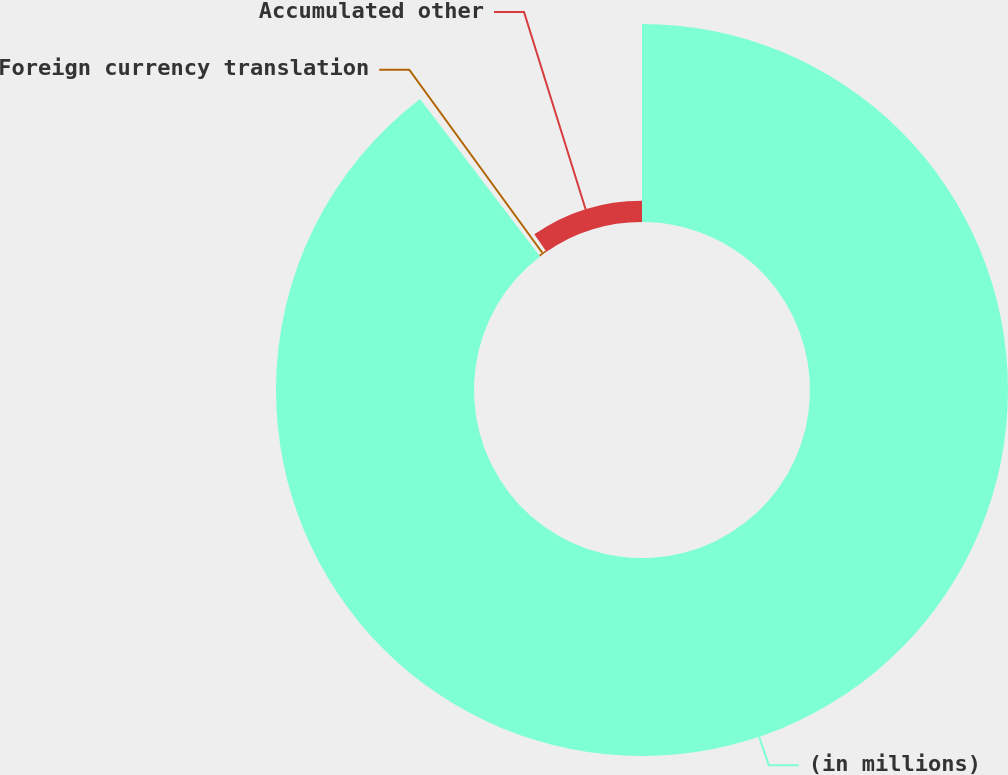Convert chart. <chart><loc_0><loc_0><loc_500><loc_500><pie_chart><fcel>(in millions)<fcel>Foreign currency translation<fcel>Accumulated other<nl><fcel>89.63%<fcel>0.74%<fcel>9.63%<nl></chart> 